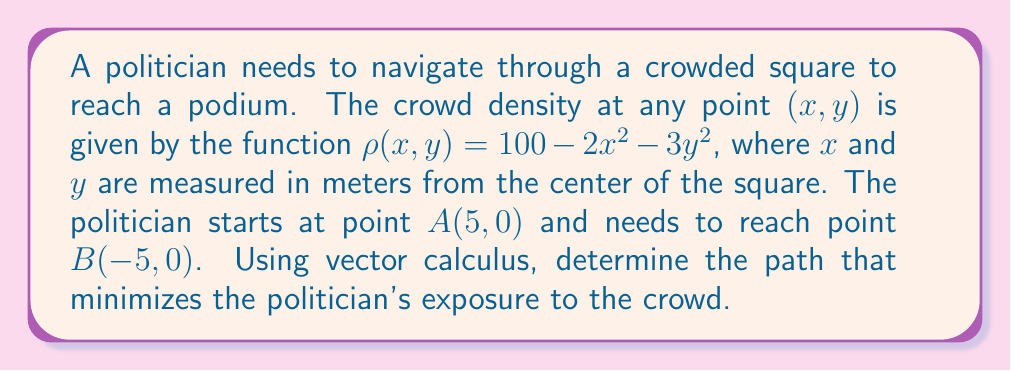Could you help me with this problem? To find the optimal path, we need to minimize the line integral of the crowd density function along the path. We can use the Euler-Lagrange equation from calculus of variations.

Step 1: Set up the functional to be minimized.
The functional is:
$$J = \int_{A}^{B} \rho(x,y) ds = \int_{A}^{B} (100 - 2x^2 - 3y^2) \sqrt{1 + (\frac{dy}{dx})^2} dx$$

Step 2: Apply the Euler-Lagrange equation.
$$\frac{\partial F}{\partial y} - \frac{d}{dx}\left(\frac{\partial F}{\partial y'}\right) = 0$$
where $F = (100 - 2x^2 - 3y^2) \sqrt{1 + (y')^2}$

Step 3: Solve the Euler-Lagrange equation.
After simplification, we get:
$$\frac{d}{dx}\left(\frac{(100 - 2x^2 - 3y^2)y'}{\sqrt{1 + (y')^2}}\right) = -6y(100 - 2x^2 - 3y^2)$$

Step 4: Recognize the symmetry of the problem.
Due to the symmetry of the density function and the start and end points, the optimal path will be symmetric about the y-axis.

Step 5: Conclude the shape of the optimal path.
The solution to this differential equation is a catenary curve, which can be expressed as:
$$y = a \cosh(\frac{x}{a})$$
where $a$ is a constant that needs to be determined based on the boundary conditions.

Step 6: Determine the constant $a$.
Given that the path passes through points $(5,0)$ and $(-5,0)$, we can solve:
$$0 = a \cosh(\frac{5}{a})$$
This equation can be solved numerically to find $a \approx 4.0815$.

Therefore, the optimal path is described by the equation:
$$y = 4.0815 \cosh(\frac{x}{4.0815})$$
Answer: $y = 4.0815 \cosh(\frac{x}{4.0815})$ 